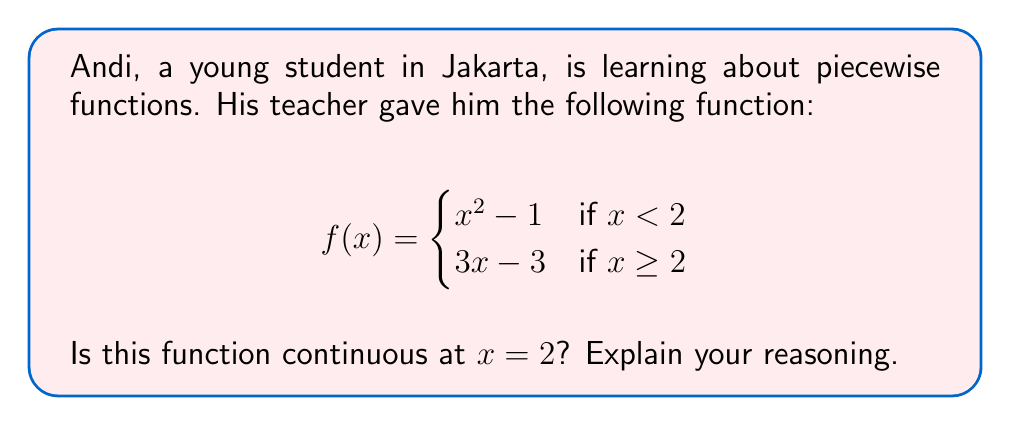Could you help me with this problem? To determine if the function is continuous at $x = 2$, we need to check three conditions:

1. The function must be defined at $x = 2$.
2. The limit of the function as $x$ approaches 2 from the left must exist.
3. The limit of the function as $x$ approaches 2 from the right must exist.
4. The two one-sided limits must be equal to each other and to $f(2)$.

Let's check these conditions:

1. $f(2)$ is defined: $f(2) = 3(2) - 3 = 3$

2. Left-hand limit:
   $\lim_{x \to 2^-} f(x) = \lim_{x \to 2^-} (x^2 - 1) = 2^2 - 1 = 3$

3. Right-hand limit:
   $\lim_{x \to 2^+} f(x) = \lim_{x \to 2^+} (3x - 3) = 3(2) - 3 = 3$

4. Both limits equal $f(2)$:
   $\lim_{x \to 2^-} f(x) = \lim_{x \to 2^+} f(x) = f(2) = 3$

Since all conditions are satisfied, the function is continuous at $x = 2$.
Answer: Yes, the function is continuous at $x = 2$. 